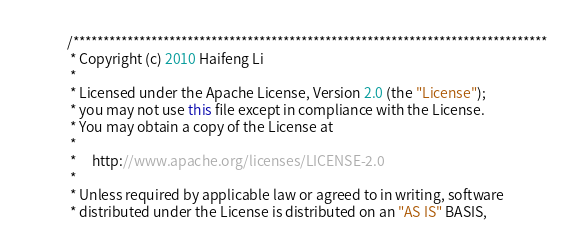<code> <loc_0><loc_0><loc_500><loc_500><_Java_>/*******************************************************************************
 * Copyright (c) 2010 Haifeng Li
 *   
 * Licensed under the Apache License, Version 2.0 (the "License");
 * you may not use this file except in compliance with the License.
 * You may obtain a copy of the License at
 *  
 *     http://www.apache.org/licenses/LICENSE-2.0
 *
 * Unless required by applicable law or agreed to in writing, software
 * distributed under the License is distributed on an "AS IS" BASIS,</code> 